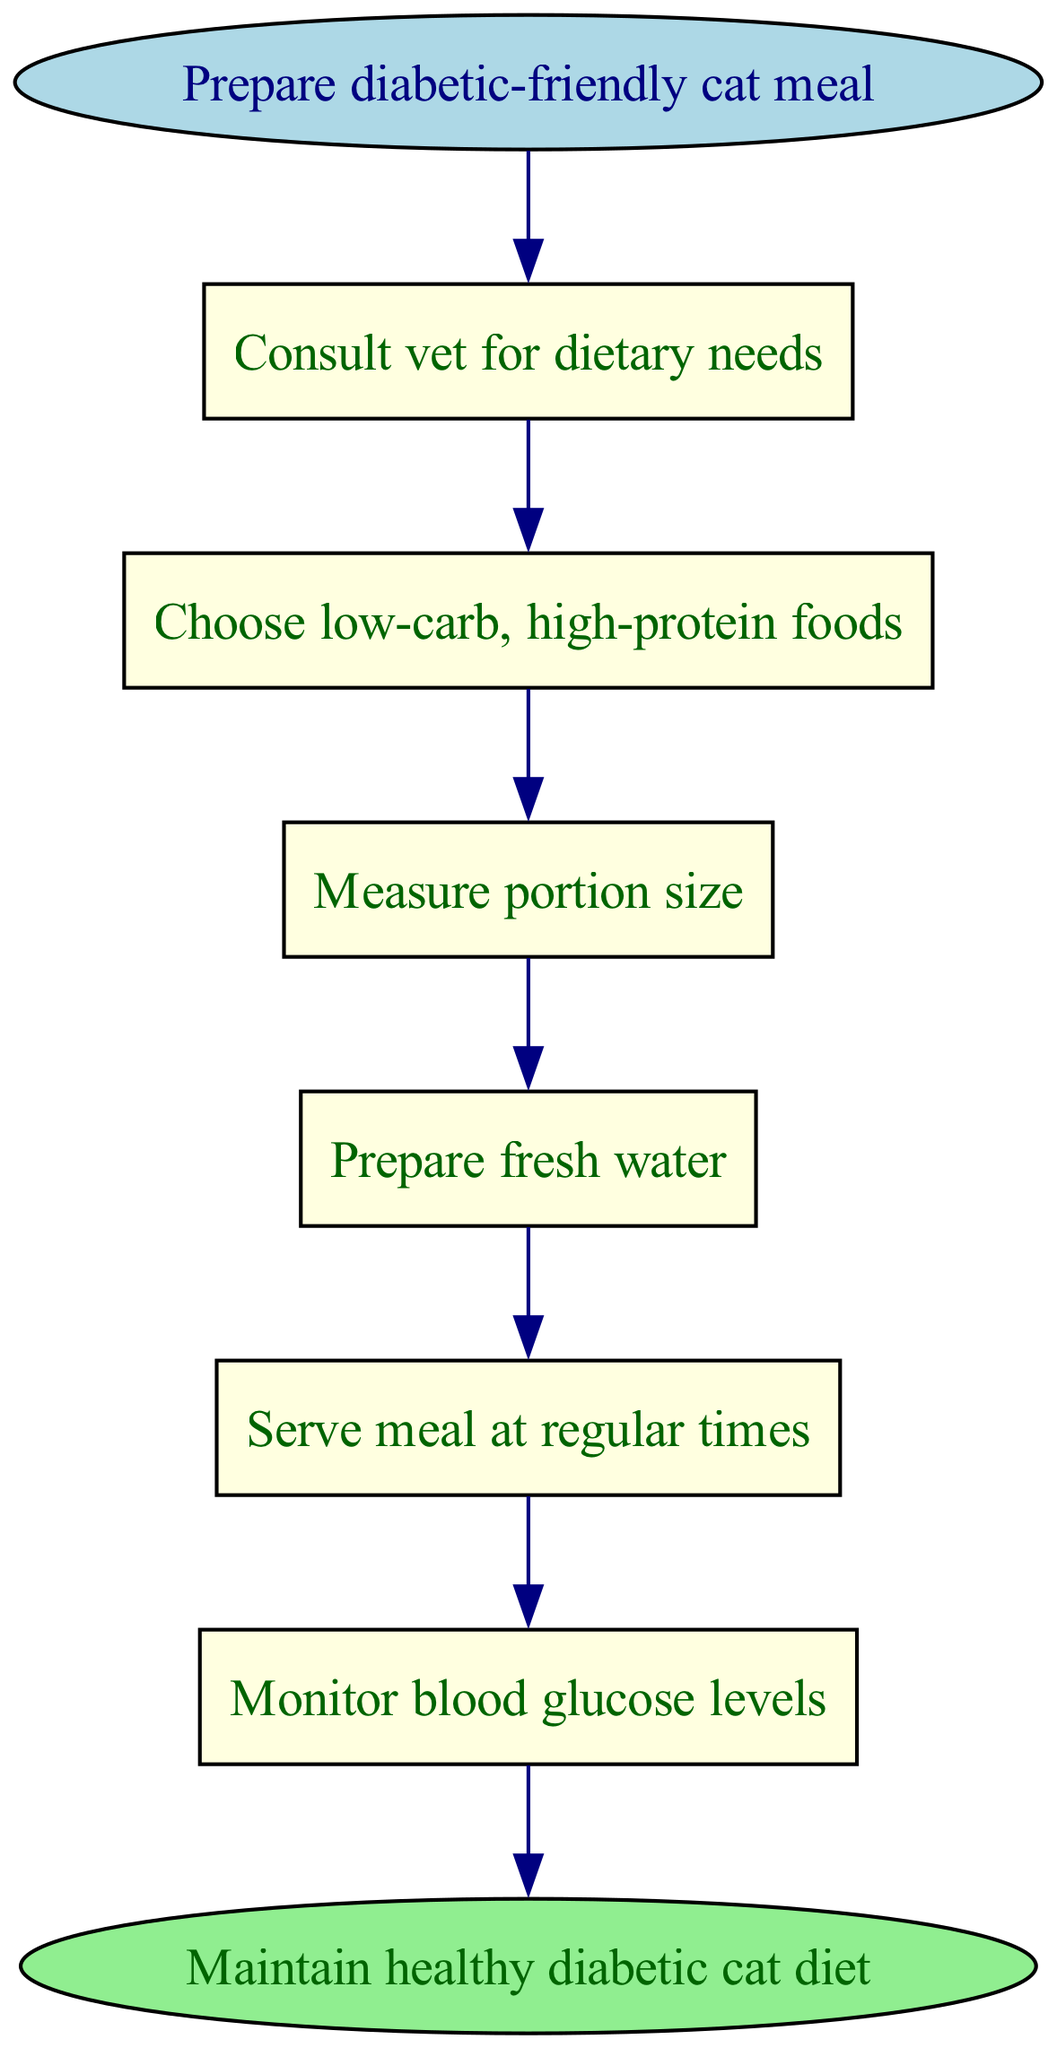What is the first step in preparing a diabetic-friendly meal? The diagram indicates that the first step is to "Consult vet for dietary needs." This is the first action listed in the flow chart under the start node.
Answer: Consult vet for dietary needs How many steps are there in total? The diagram lists a total of six steps, including the end node. These steps form a sequential flow from start to finish, leading to the endpoint for maintaining a healthy diabetic cat diet.
Answer: Six What type of food should be chosen for the meal? According to the flow chart, the second step specifically mentions to "Choose low-carb, high-protein foods," indicating the recommended food type.
Answer: Low-carb, high-protein foods What do you do after measuring the portion size? The flow chart outlines that after "Measure portion size," the next step is to "Prepare fresh water." This indicates the action to be taken immediately after portion sizing.
Answer: Prepare fresh water What is the last step in this process? The diagram shows that the last step, before reaching the end node, is to "Monitor blood glucose levels." This final action ensures the health of the diabetic cat is continuously observed.
Answer: Monitor blood glucose levels What two nodes are directly connected to the starting node? The start node is connected to only one node, which is "Consult vet for dietary needs," as indicated by the arrow leading directly from start to step one.
Answer: Consult vet for dietary needs What is done after serving the meal? The diagram states that after serving the meal at regular times, the next step is to "Monitor blood glucose levels." This indicates a sequence of actions following the meal serving.
Answer: Monitor blood glucose levels How does the flow chart conclude? The flow chart concludes with the end node stating "Maintain healthy diabetic cat diet," indicating a summary of the overall purpose for the steps conducted throughout the process.
Answer: Maintain healthy diabetic cat diet 